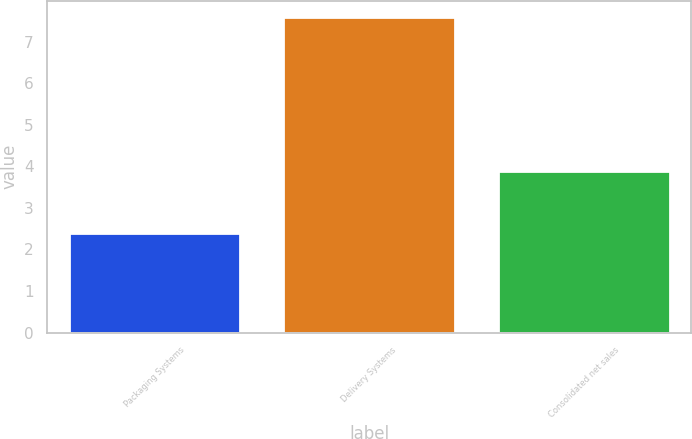<chart> <loc_0><loc_0><loc_500><loc_500><bar_chart><fcel>Packaging Systems<fcel>Delivery Systems<fcel>Consolidated net sales<nl><fcel>2.4<fcel>7.6<fcel>3.9<nl></chart> 